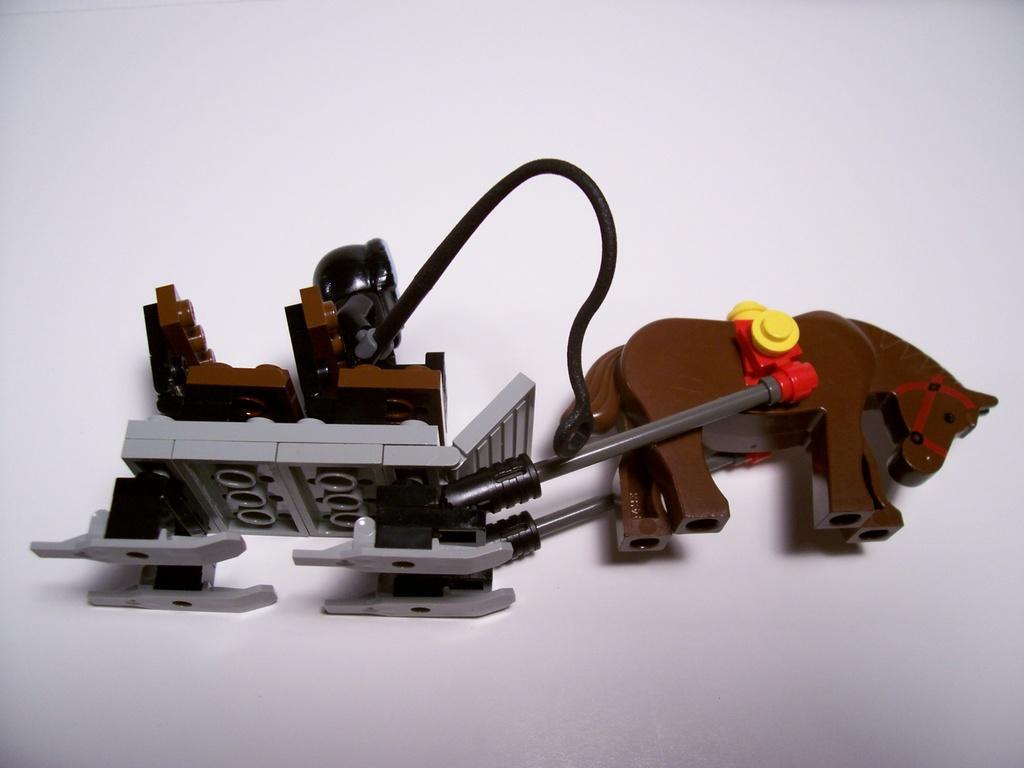Could you give a brief overview of what you see in this image? In this image we can see a toy on a white surface. 